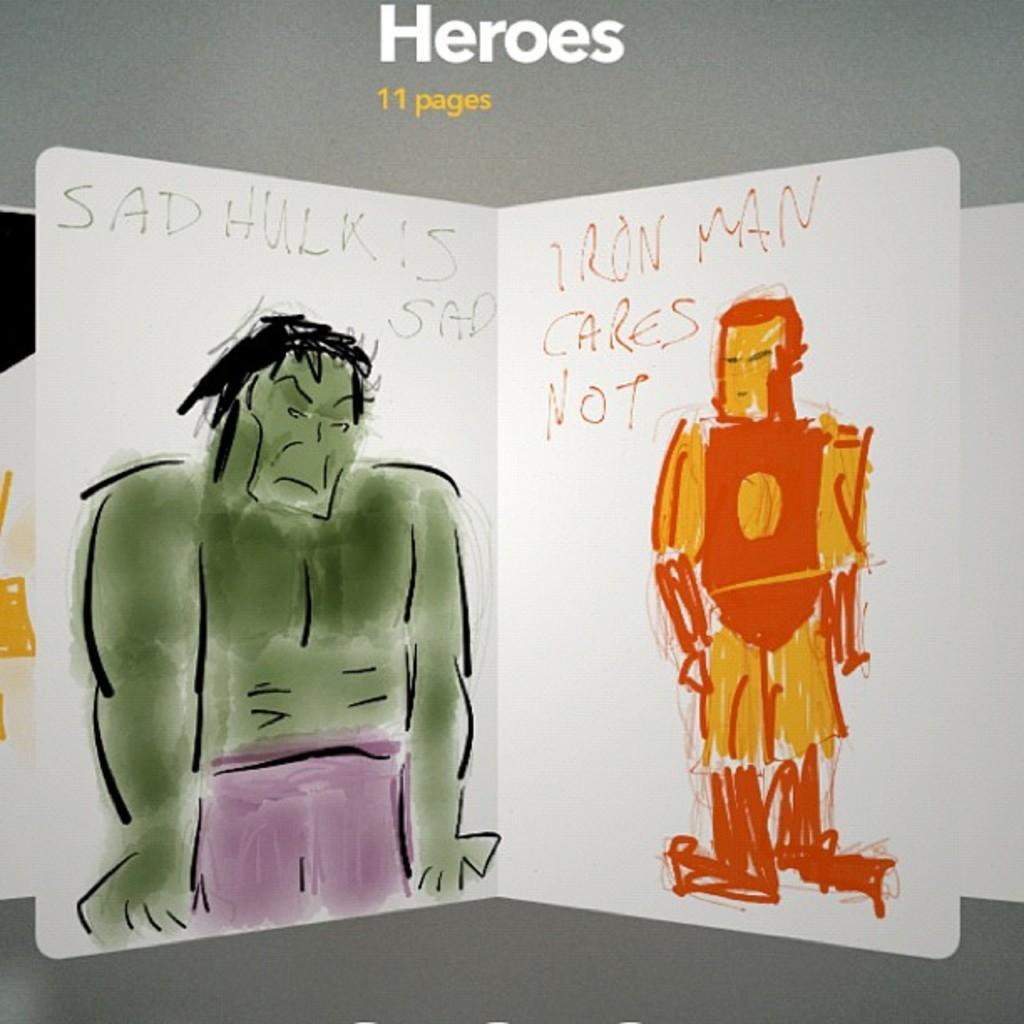In one or two sentences, can you explain what this image depicts? In this picture we can see painting, we can see painting of a hulk and an iron man , there is some text here. 